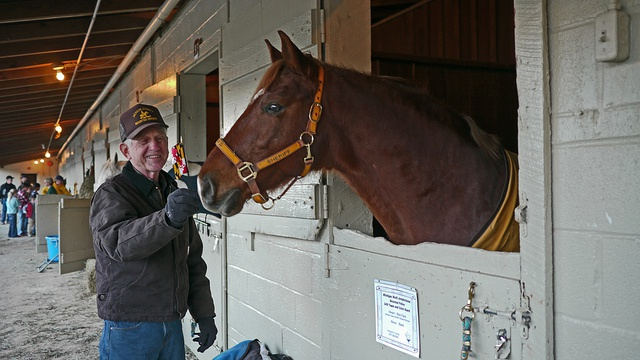Describe the objects in this image and their specific colors. I can see horse in black, maroon, and gray tones, people in black, gray, darkblue, and blue tones, people in black, maroon, gray, and navy tones, people in black, blue, navy, and lightblue tones, and people in black, darkgray, navy, and gray tones in this image. 